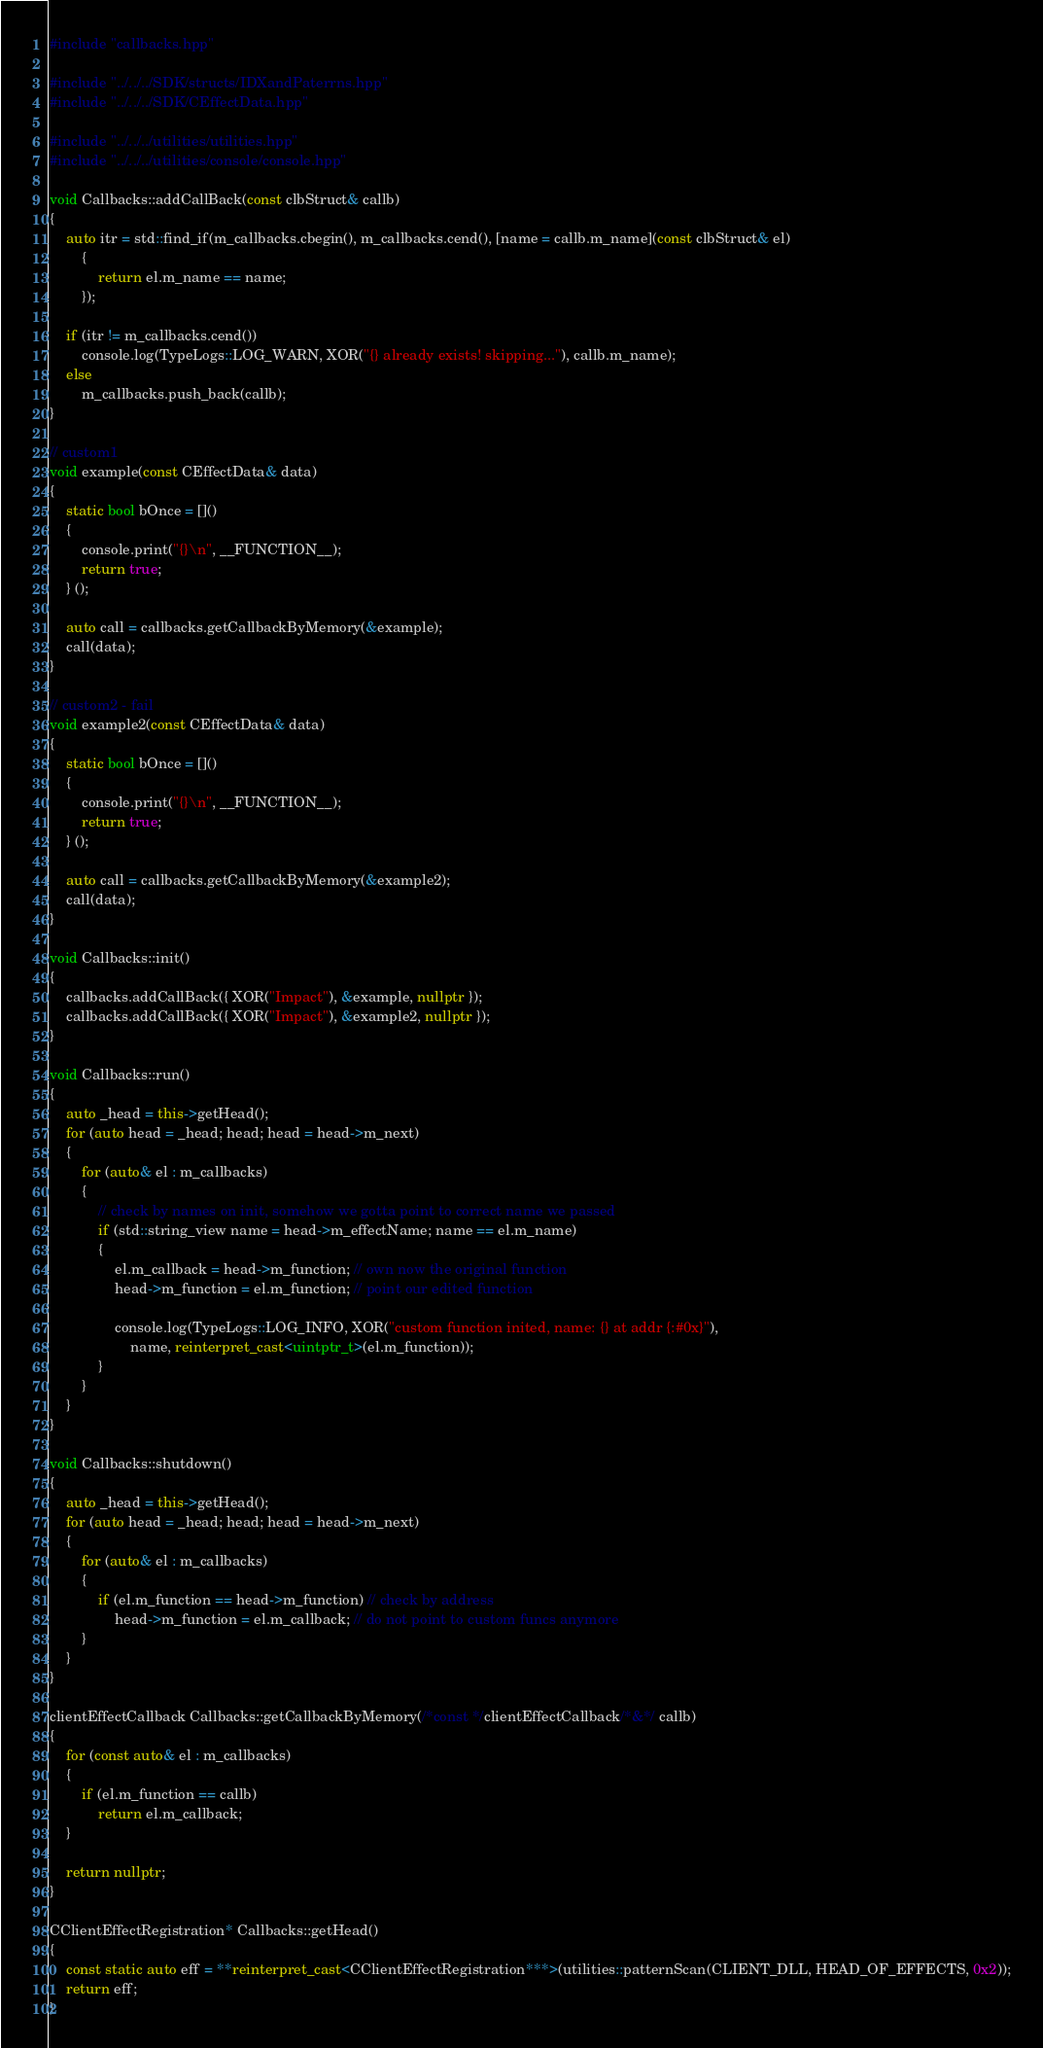<code> <loc_0><loc_0><loc_500><loc_500><_C++_>#include "callbacks.hpp"

#include "../../../SDK/structs/IDXandPaterrns.hpp"
#include "../../../SDK/CEffectData.hpp"

#include "../../../utilities/utilities.hpp"
#include "../../../utilities/console/console.hpp"

void Callbacks::addCallBack(const clbStruct& callb)
{
    auto itr = std::find_if(m_callbacks.cbegin(), m_callbacks.cend(), [name = callb.m_name](const clbStruct& el)
        {
            return el.m_name == name;
        });

    if (itr != m_callbacks.cend())
        console.log(TypeLogs::LOG_WARN, XOR("{} already exists! skipping..."), callb.m_name);
    else
        m_callbacks.push_back(callb);
}

// custom1
void example(const CEffectData& data)
{
    static bool bOnce = []()
    {
        console.print("{}\n", __FUNCTION__);
        return true;
    } ();

    auto call = callbacks.getCallbackByMemory(&example);
    call(data);
}

// custom2 - fail
void example2(const CEffectData& data)
{
    static bool bOnce = []()
    {
        console.print("{}\n", __FUNCTION__);
        return true;
    } ();

    auto call = callbacks.getCallbackByMemory(&example2);
    call(data);
}

void Callbacks::init()
{
    callbacks.addCallBack({ XOR("Impact"), &example, nullptr });
    callbacks.addCallBack({ XOR("Impact"), &example2, nullptr });
}

void Callbacks::run()
{
    auto _head = this->getHead();
    for (auto head = _head; head; head = head->m_next)
    {
        for (auto& el : m_callbacks)
        {
            // check by names on init, somehow we gotta point to correct name we passed
            if (std::string_view name = head->m_effectName; name == el.m_name)
            {
                el.m_callback = head->m_function; // own now the original function
                head->m_function = el.m_function; // point our edited function

                console.log(TypeLogs::LOG_INFO, XOR("custom function inited, name: {} at addr {:#0x}"),
                    name, reinterpret_cast<uintptr_t>(el.m_function));
            }
        }
    }
}

void Callbacks::shutdown()
{
    auto _head = this->getHead();
    for (auto head = _head; head; head = head->m_next)
    {
        for (auto& el : m_callbacks)
        {
            if (el.m_function == head->m_function) // check by address
                head->m_function = el.m_callback; // do not point to custom funcs anymore
        }
    }
}

clientEffectCallback Callbacks::getCallbackByMemory(/*const */clientEffectCallback/*&*/ callb)
{
    for (const auto& el : m_callbacks)
    {
        if (el.m_function == callb)
            return el.m_callback;
    }

    return nullptr;
}

CClientEffectRegistration* Callbacks::getHead()
{
    const static auto eff = **reinterpret_cast<CClientEffectRegistration***>(utilities::patternScan(CLIENT_DLL, HEAD_OF_EFFECTS, 0x2));
    return eff;
}</code> 